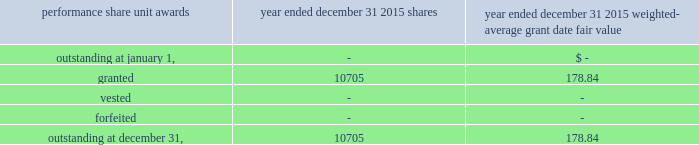The table summarized the status of the company 2019s non-vested performance share unit awards and changes for the period indicated : weighted- average grant date performance share unit awards shares fair value .
19 .
Segment reporting the u.s .
Reinsurance operation writes property and casualty reinsurance and specialty lines of business , including marine , aviation , surety and accident and health ( 201ca&h 201d ) business , on both a treaty and facultative basis , through reinsurance brokers , as well as directly with ceding companies primarily within the u.s .
The international operation writes non-u.s .
Property and casualty reinsurance through everest re 2019s branches in canada and singapore and through offices in brazil , miami and new jersey .
The bermuda operation provides reinsurance and insurance to worldwide property and casualty markets through brokers and directly with ceding companies from its bermuda office and reinsurance to the united kingdom and european markets through its uk branch and ireland re .
The insurance operation writes property and casualty insurance directly and through general agents , brokers and surplus lines brokers within the u.s .
And canada .
The mt .
Logan re segment represents business written for the segregated accounts of mt .
Logan re , which were formed on july 1 , 2013 .
The mt .
Logan re business represents a diversified set of catastrophe exposures , diversified by risk/peril and across different geographical regions globally .
These segments , with the exception of mt .
Logan re , are managed independently , but conform with corporate guidelines with respect to pricing , risk management , control of aggregate catastrophe exposures , capital , investments and support operations .
Management generally monitors and evaluates the financial performance of these operating segments based upon their underwriting results .
The mt .
Logan re segment is managed independently and seeks to write a diverse portfolio of catastrophe risks for each segregated account to achieve desired risk and return criteria .
Underwriting results include earned premium less losses and loss adjustment expenses ( 201clae 201d ) incurred , commission and brokerage expenses and other underwriting expenses .
We measure our underwriting results using ratios , in particular loss , commission and brokerage and other underwriting expense ratios , which , respectively , divide incurred losses , commissions and brokerage and other underwriting expenses by premiums earned .
Mt .
Logan re 2019s business is sourced through operating subsidiaries of the company ; however , the activity is only reflected in the mt .
Logan re segment .
For other inter-affiliate reinsurance , business is generally reported within the segment in which the business was first produced , consistent with how the business is managed .
Except for mt .
Logan re , the company does not maintain separate balance sheet data for its operating segments .
Accordingly , the company does not review and evaluate the financial results of its operating segments based upon balance sheet data. .
As of year ended december 31 2015 what is the value of the shares granted? 
Computations: (10705 * 178.84)
Answer: 1914482.2. 